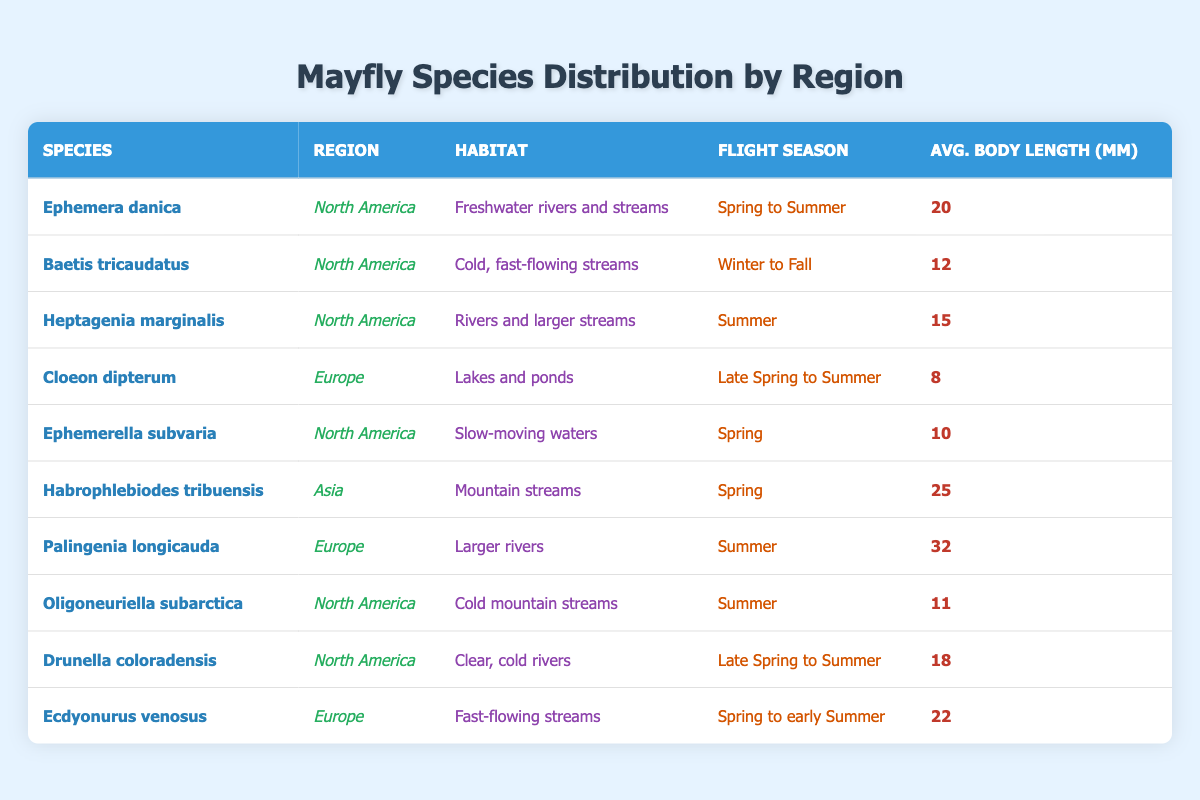What is the average body length of *Ephemera danica*? The average body length for *Ephemera danica* is listed in the table as 20 mm.
Answer: 20 mm Which region has the mayfly species with the longest average body length? The longest average body length is 32 mm for *Palingenia longicauda* in Europe, making it the species with the longest body length in the table.
Answer: Europe How many mayfly species are found in North America? The table lists 5 mayfly species from North America: *Ephemera danica*, *Baetis tricaudatus*, *Heptagenia marginalis*, *Ephemerella subvaria*, *Oligoneuriella subarctica*, and *Drunella coloradensis*.
Answer: 6 species Is there any mayfly species that lives in lakes and ponds? Yes, *Cloeon dipterum* is identified in the table as living in lakes and ponds.
Answer: Yes What is the flight season for *Habrophlebiodes tribuensis*? The flight season for *Habrophlebiodes tribuensis* is listed as "Spring" in the table.
Answer: Spring How does the average body length of *Oligoneuriella subarctica* compare to the average body length of *Cloeon dipterum*? The average body length of *Oligoneuriella subarctica* is 11 mm, while *Cloeon dipterum* has an average body length of 8 mm. Therefore, *Oligoneuriella subarctica* is longer. The difference is 11 mm - 8 mm = 3 mm.
Answer: 3 mm longer Which species has the earliest flight season based on the data? The earliest flight season is seen for *Ephemerella subvaria*, which flies in "Spring". This is the only one with a specified flight season that begins in Spring without extending into later seasons.
Answer: Ephemerella subvaria In which region do mayflies have the shortest average body length? Evaluating the average body lengths, *Cloeon dipterum* in Europe has the shortest length of 8 mm, making it the species with the shortest average body length.
Answer: Europe What is the total number of regions mentioned in the table? The regions mentioned in the table are North America, Europe, and Asia. Therefore, there are 3 distinct regions listed.
Answer: 3 regions Which species is found in fast-flowing streams? The species found in fast-flowing streams is *Baetis tricaudatus* from North America and *Ecdyonurus venosus* from Europe, according to the table.
Answer: Baetis tricaudatus and Ecdyonurus venosus How many mayfly species have a flight season that includes Summer? The species with a flight season that includes Summer are *Ephemera danica*, *Heptagenia marginalis*, *Oligoneuriella subarctica*, *Drunella coloradensis*, *Palingenia longicauda*, and *Ecdyonurus venosus*. Counting these gives us 6 species.
Answer: 6 species 